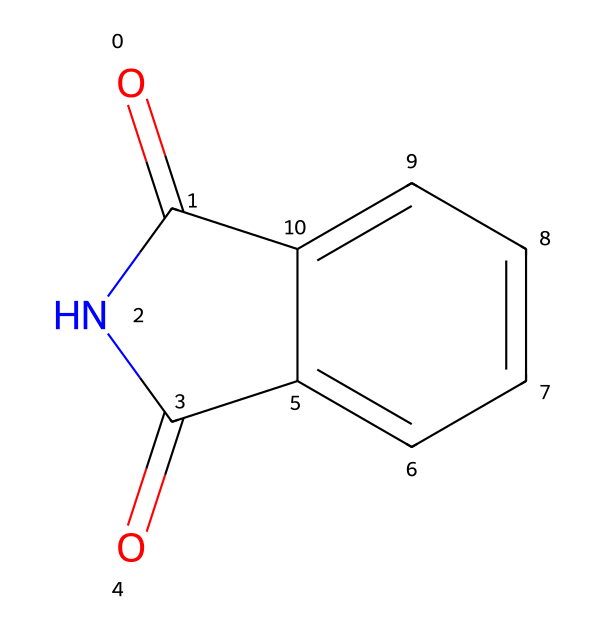What is the molecular formula of phthalimide? To determine the molecular formula, we count the number of each type of atom in the SMILES representation. In the structure O=C1NC(=O)c2ccccc21, there are 8 carbon atoms, 5 hydrogen atoms, 2 nitrogen atoms, and 2 oxygen atoms. Therefore, the molecular formula is C8H5N2O2.
Answer: C8H5N2O2 How many nitrogen atoms are present in phthalimide? In the given SMILES representation, we can identify the nitrogen atoms by observing the presence of 'N' symbols in the structure. There are exactly 2 nitrogen atoms in the structure of phthalimide.
Answer: 2 What type of functional groups are present in phthalimide? Analyzing the SMILES, we see carbonyl groups (C=O) and an imide (N-C(O) groups), which are characteristic of imides. Thus, phthalimide contains carbonyl and imide functional groups.
Answer: carbonyl and imide Is phthalimide aromatic? The compound features a cyclic structure that includes a benzene ring (noted by 'c' in the SMILES), which indicates that it has delocalized pi electrons and thus fits the definition of aromaticity.
Answer: yes What is the total number of rings in phthalimide? The SMILES indicates that there are two rings in the structure: one is the aromatic benzene ring, and the other is part of the imide formation with the nitrogen atom involved in the cycle. Thus, the total number of rings is 2.
Answer: 2 Does phthalimide have a planar structure? Given that phthalimide includes a conjugated system with an aromatic ring and several sp2 hybridized atoms, it implies that the molecule is planar in nature due to the arrangement of atoms and bonds in its structure.
Answer: yes 